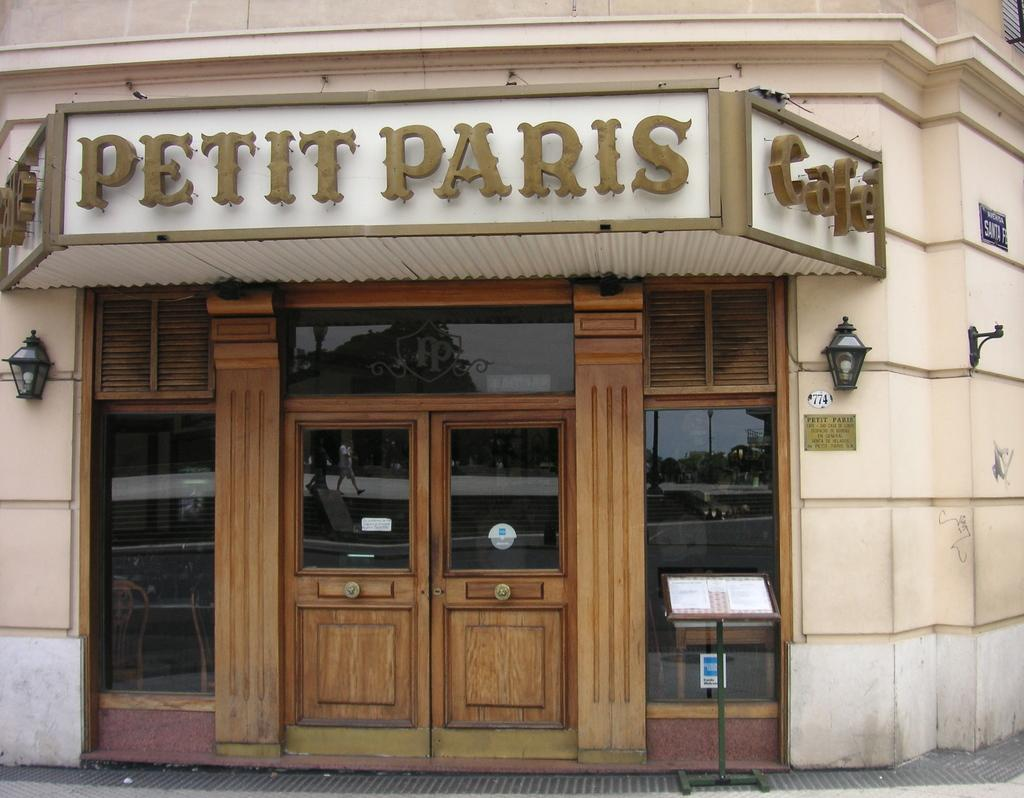What is on the floor in the image? There is a stand on the floor in the image. What can be seen on the stand? The stand is holding name boards in the image. What architectural features are present in the image? There are doors and a wall in the image. What type of lighting is present in the image? There are lamps in the image. Are there any other objects visible in the image? Yes, there are additional objects in the image. What type of account is being discussed in the image? There is no account being discussed in the image; it features a stand with name boards, doors, a wall, lamps, and additional objects. Is there a church visible in the image? No, there is no church present in the image. 